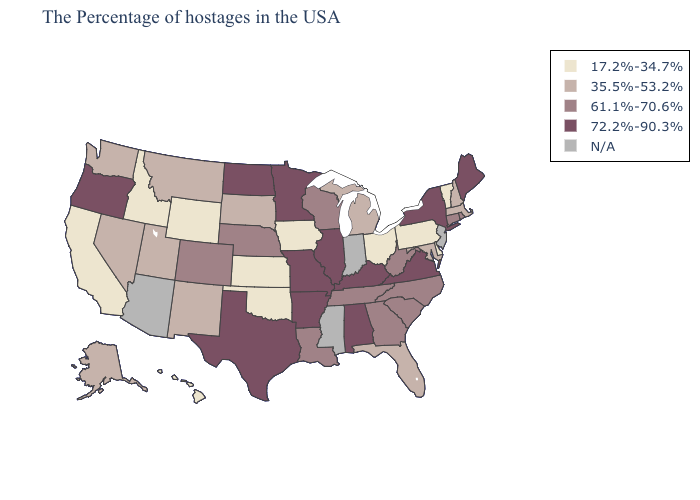Name the states that have a value in the range 61.1%-70.6%?
Quick response, please. Rhode Island, Connecticut, North Carolina, South Carolina, West Virginia, Georgia, Tennessee, Wisconsin, Louisiana, Nebraska, Colorado. Does the map have missing data?
Answer briefly. Yes. What is the highest value in states that border West Virginia?
Short answer required. 72.2%-90.3%. Among the states that border Ohio , does West Virginia have the highest value?
Keep it brief. No. Which states have the lowest value in the USA?
Give a very brief answer. Vermont, Delaware, Pennsylvania, Ohio, Iowa, Kansas, Oklahoma, Wyoming, Idaho, California, Hawaii. Among the states that border Connecticut , does Rhode Island have the highest value?
Quick response, please. No. Name the states that have a value in the range N/A?
Short answer required. New Jersey, Indiana, Mississippi, Arizona. Among the states that border Indiana , does Ohio have the lowest value?
Be succinct. Yes. Name the states that have a value in the range 61.1%-70.6%?
Answer briefly. Rhode Island, Connecticut, North Carolina, South Carolina, West Virginia, Georgia, Tennessee, Wisconsin, Louisiana, Nebraska, Colorado. Which states have the highest value in the USA?
Short answer required. Maine, New York, Virginia, Kentucky, Alabama, Illinois, Missouri, Arkansas, Minnesota, Texas, North Dakota, Oregon. What is the value of Wyoming?
Be succinct. 17.2%-34.7%. What is the highest value in states that border North Carolina?
Answer briefly. 72.2%-90.3%. Name the states that have a value in the range 35.5%-53.2%?
Concise answer only. Massachusetts, New Hampshire, Maryland, Florida, Michigan, South Dakota, New Mexico, Utah, Montana, Nevada, Washington, Alaska. How many symbols are there in the legend?
Give a very brief answer. 5. 